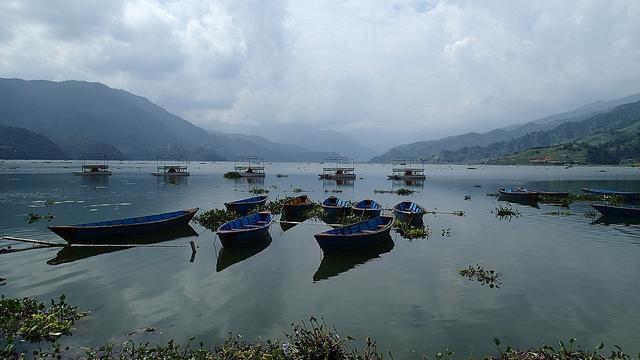How many boats are in the photo?
Give a very brief answer. 2. 